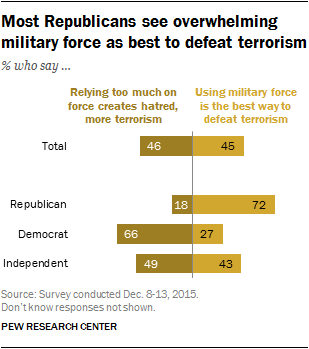Mention a couple of crucial points in this snapshot. There are more bars in the "Democrat" category than in the "Republican" category, with a ratio of approximately 2.76875 to 1. The value of the largest bar in Total is 46. 